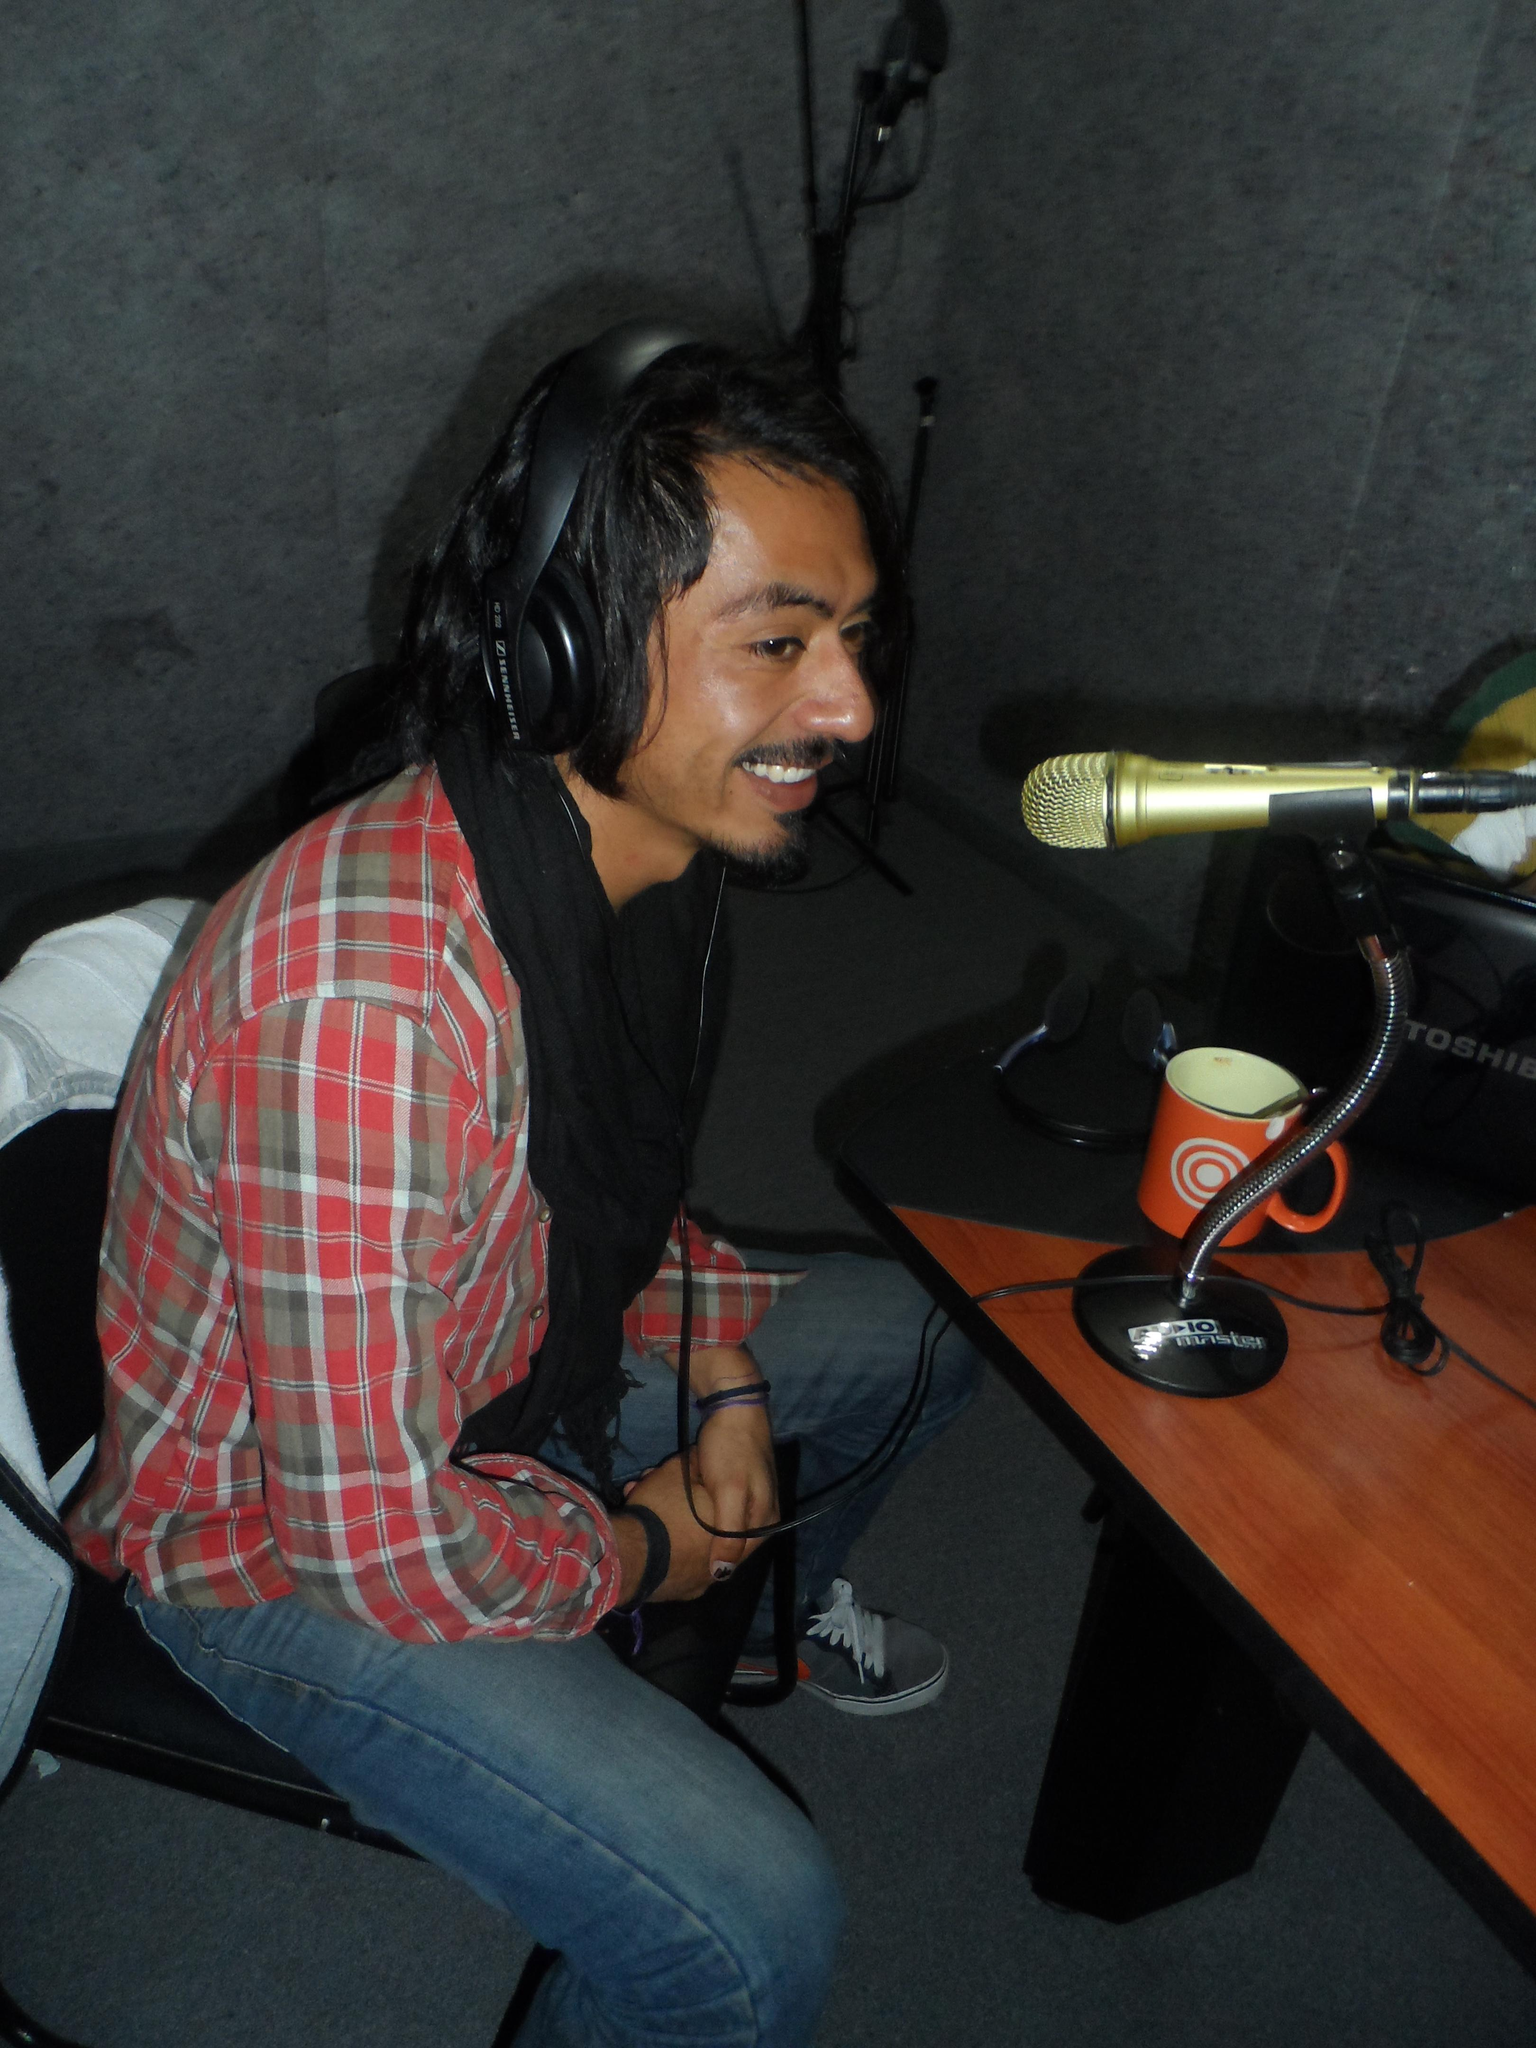Who is present in the image? There is a man in the image. What is the man doing in the image? The man is sitting in a chair and talking into a microphone. What is the man's facial expression in the image? The man is smiling in the image. Where is the microphone located in the image? The microphone is on a table in the image. What other objects are on the table in the image? There is a cup and a bag on the table in the image. What type of hat is the man wearing in the image? There is no hat present in the image. What is the material of the slope in the image? There is no slope present in the image. 